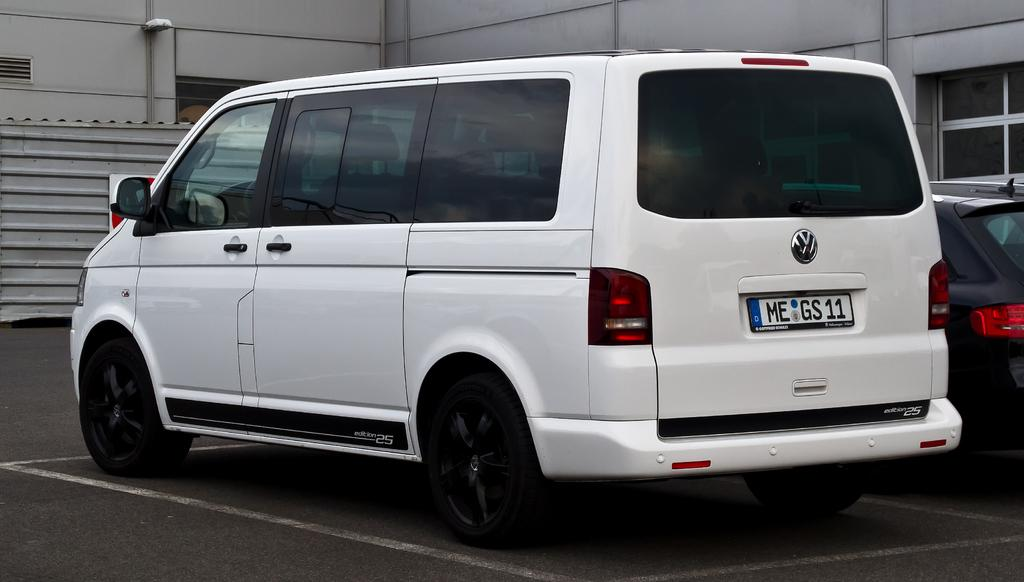<image>
Offer a succinct explanation of the picture presented. A white Volkswagen van is parked in a parking spot. 